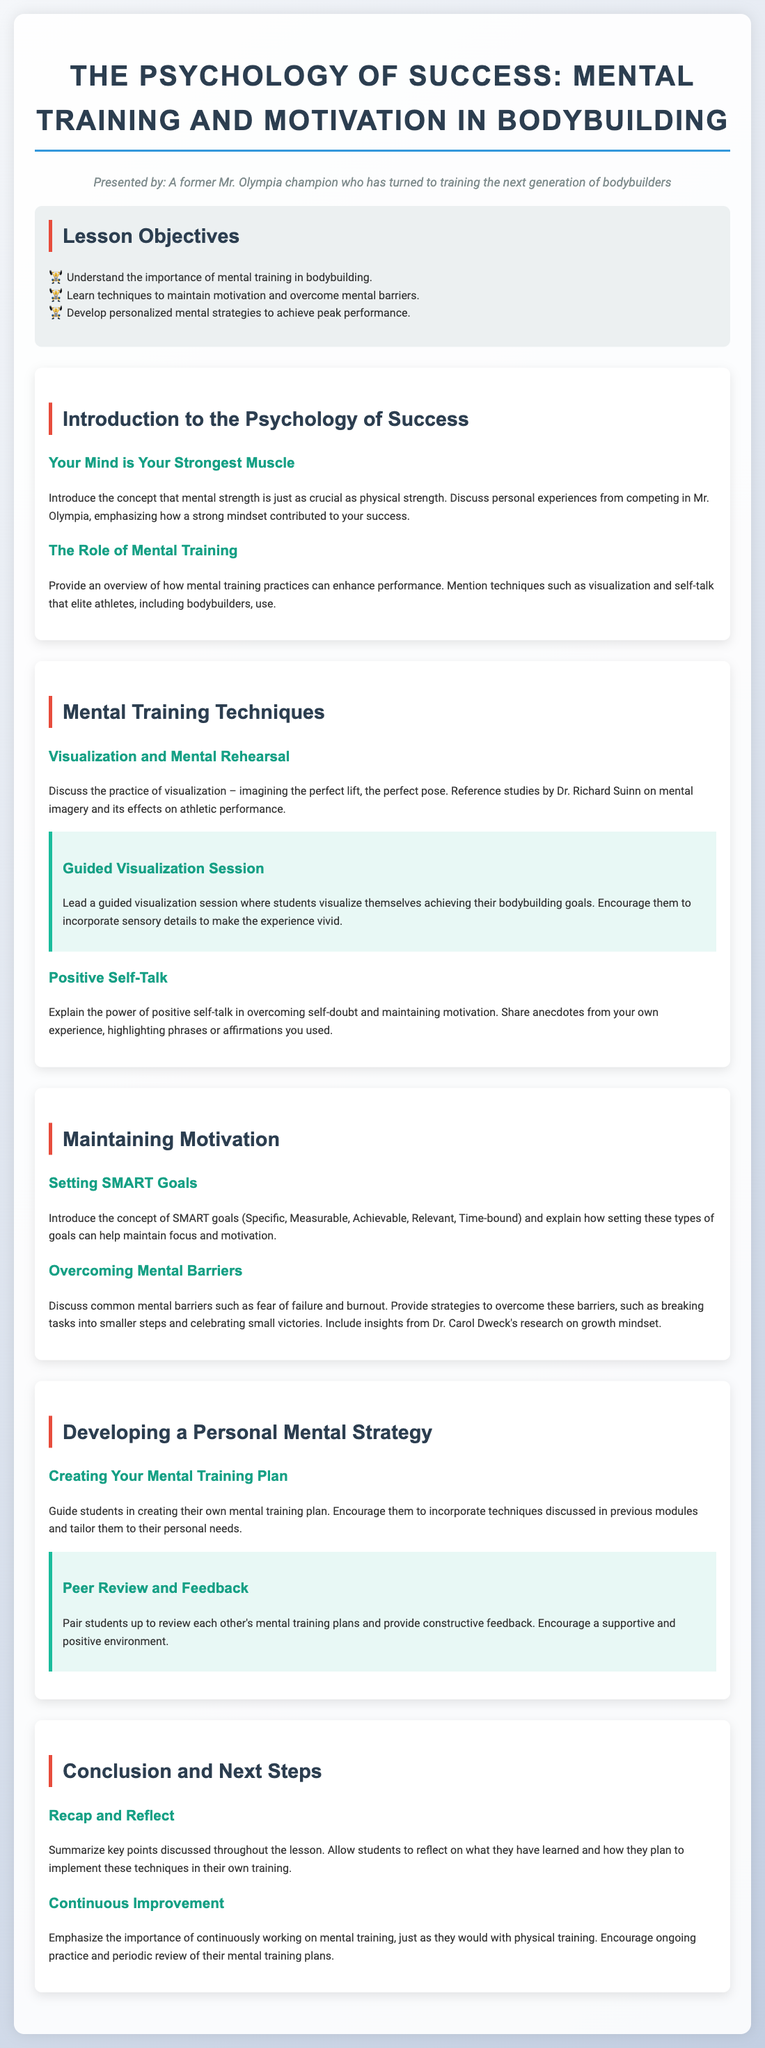What is the title of the lesson? The title is provided in the <h1> tag at the top of the document, which states the focus of the lesson.
Answer: The Psychology of Success: Mental Training and Motivation in Bodybuilding Who presented the lesson? The presenter is identified in the persona section of the document, highlighting their background.
Answer: A former Mr. Olympia champion What is one of the objectives of the lesson? The objectives are listed in the "Lesson Objectives" section; one of them is important for understanding mental training benefits.
Answer: Understand the importance of mental training in bodybuilding What is a mental training technique mentioned in the lesson? Techniques are discussed in the "Mental Training Techniques" module, with several examples provided.
Answer: Visualization Which concept helps maintain motivation according to the document? The lesson describes SMART goals as essential for keeping focus and motivation, outlining its components.
Answer: SMART goals What is one common mental barrier discussed in the module? This information can be found in the "Overcoming Mental Barriers" section, which mentions specific challenges athletes face.
Answer: Fear of failure What activity involves peer review in the lesson plan? This activity is part of the module focused on creating a personal mental strategy, encouraging collaboration among students.
Answer: Peer Review and Feedback Which author's research is referenced regarding growth mindset? The document refers to a prominent psychologist whose work on mindset is relevant to overcoming barriers in training.
Answer: Dr. Carol Dweck What is a key takeaway from the conclusion section? The conclusion emphasizes the ongoing nature of mental training, paralleling it with physical training efforts mentioned earlier.
Answer: Continuous Improvement 